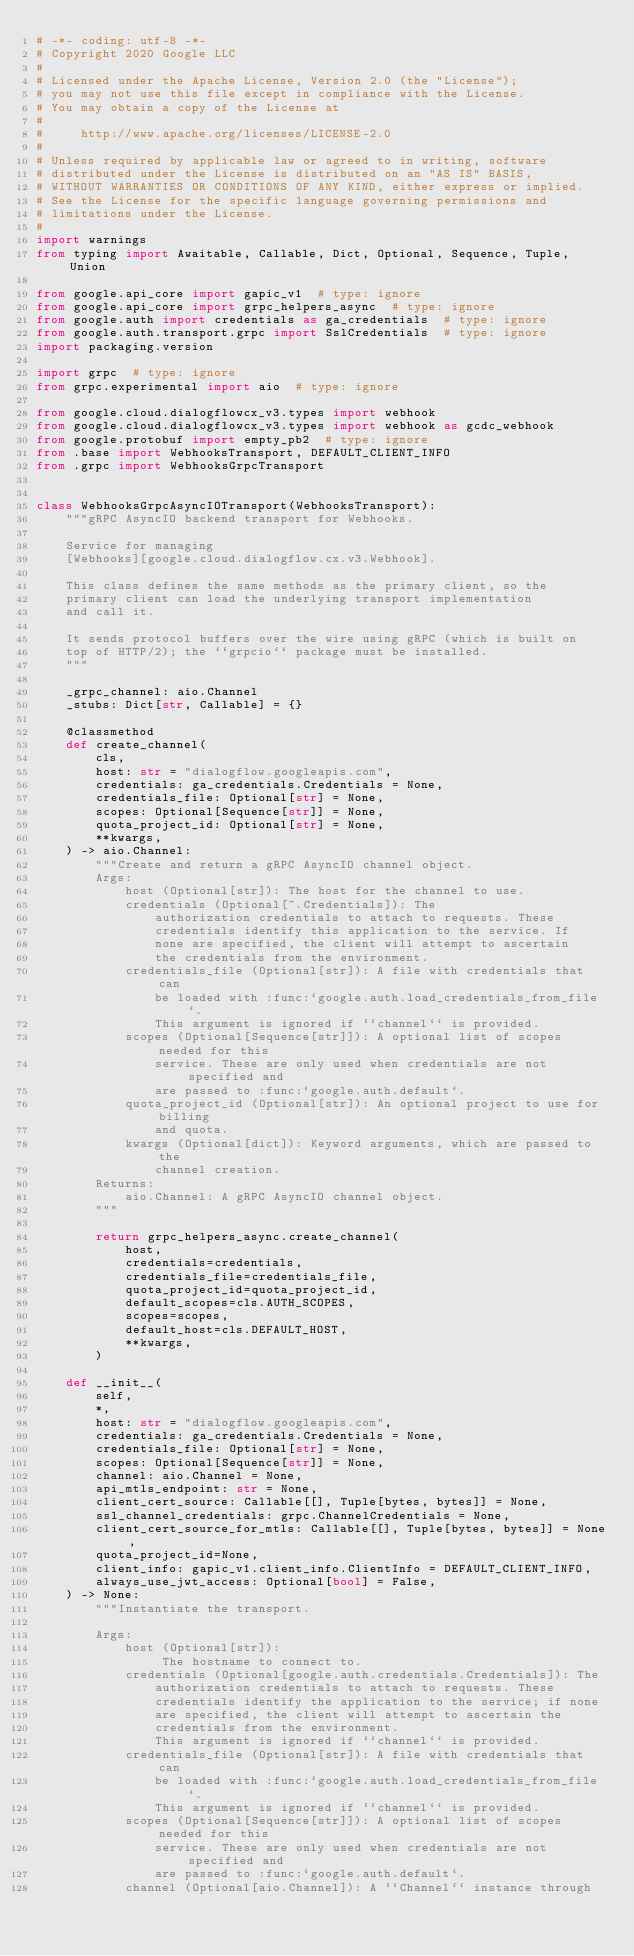<code> <loc_0><loc_0><loc_500><loc_500><_Python_># -*- coding: utf-8 -*-
# Copyright 2020 Google LLC
#
# Licensed under the Apache License, Version 2.0 (the "License");
# you may not use this file except in compliance with the License.
# You may obtain a copy of the License at
#
#     http://www.apache.org/licenses/LICENSE-2.0
#
# Unless required by applicable law or agreed to in writing, software
# distributed under the License is distributed on an "AS IS" BASIS,
# WITHOUT WARRANTIES OR CONDITIONS OF ANY KIND, either express or implied.
# See the License for the specific language governing permissions and
# limitations under the License.
#
import warnings
from typing import Awaitable, Callable, Dict, Optional, Sequence, Tuple, Union

from google.api_core import gapic_v1  # type: ignore
from google.api_core import grpc_helpers_async  # type: ignore
from google.auth import credentials as ga_credentials  # type: ignore
from google.auth.transport.grpc import SslCredentials  # type: ignore
import packaging.version

import grpc  # type: ignore
from grpc.experimental import aio  # type: ignore

from google.cloud.dialogflowcx_v3.types import webhook
from google.cloud.dialogflowcx_v3.types import webhook as gcdc_webhook
from google.protobuf import empty_pb2  # type: ignore
from .base import WebhooksTransport, DEFAULT_CLIENT_INFO
from .grpc import WebhooksGrpcTransport


class WebhooksGrpcAsyncIOTransport(WebhooksTransport):
    """gRPC AsyncIO backend transport for Webhooks.

    Service for managing
    [Webhooks][google.cloud.dialogflow.cx.v3.Webhook].

    This class defines the same methods as the primary client, so the
    primary client can load the underlying transport implementation
    and call it.

    It sends protocol buffers over the wire using gRPC (which is built on
    top of HTTP/2); the ``grpcio`` package must be installed.
    """

    _grpc_channel: aio.Channel
    _stubs: Dict[str, Callable] = {}

    @classmethod
    def create_channel(
        cls,
        host: str = "dialogflow.googleapis.com",
        credentials: ga_credentials.Credentials = None,
        credentials_file: Optional[str] = None,
        scopes: Optional[Sequence[str]] = None,
        quota_project_id: Optional[str] = None,
        **kwargs,
    ) -> aio.Channel:
        """Create and return a gRPC AsyncIO channel object.
        Args:
            host (Optional[str]): The host for the channel to use.
            credentials (Optional[~.Credentials]): The
                authorization credentials to attach to requests. These
                credentials identify this application to the service. If
                none are specified, the client will attempt to ascertain
                the credentials from the environment.
            credentials_file (Optional[str]): A file with credentials that can
                be loaded with :func:`google.auth.load_credentials_from_file`.
                This argument is ignored if ``channel`` is provided.
            scopes (Optional[Sequence[str]]): A optional list of scopes needed for this
                service. These are only used when credentials are not specified and
                are passed to :func:`google.auth.default`.
            quota_project_id (Optional[str]): An optional project to use for billing
                and quota.
            kwargs (Optional[dict]): Keyword arguments, which are passed to the
                channel creation.
        Returns:
            aio.Channel: A gRPC AsyncIO channel object.
        """

        return grpc_helpers_async.create_channel(
            host,
            credentials=credentials,
            credentials_file=credentials_file,
            quota_project_id=quota_project_id,
            default_scopes=cls.AUTH_SCOPES,
            scopes=scopes,
            default_host=cls.DEFAULT_HOST,
            **kwargs,
        )

    def __init__(
        self,
        *,
        host: str = "dialogflow.googleapis.com",
        credentials: ga_credentials.Credentials = None,
        credentials_file: Optional[str] = None,
        scopes: Optional[Sequence[str]] = None,
        channel: aio.Channel = None,
        api_mtls_endpoint: str = None,
        client_cert_source: Callable[[], Tuple[bytes, bytes]] = None,
        ssl_channel_credentials: grpc.ChannelCredentials = None,
        client_cert_source_for_mtls: Callable[[], Tuple[bytes, bytes]] = None,
        quota_project_id=None,
        client_info: gapic_v1.client_info.ClientInfo = DEFAULT_CLIENT_INFO,
        always_use_jwt_access: Optional[bool] = False,
    ) -> None:
        """Instantiate the transport.

        Args:
            host (Optional[str]):
                 The hostname to connect to.
            credentials (Optional[google.auth.credentials.Credentials]): The
                authorization credentials to attach to requests. These
                credentials identify the application to the service; if none
                are specified, the client will attempt to ascertain the
                credentials from the environment.
                This argument is ignored if ``channel`` is provided.
            credentials_file (Optional[str]): A file with credentials that can
                be loaded with :func:`google.auth.load_credentials_from_file`.
                This argument is ignored if ``channel`` is provided.
            scopes (Optional[Sequence[str]]): A optional list of scopes needed for this
                service. These are only used when credentials are not specified and
                are passed to :func:`google.auth.default`.
            channel (Optional[aio.Channel]): A ``Channel`` instance through</code> 